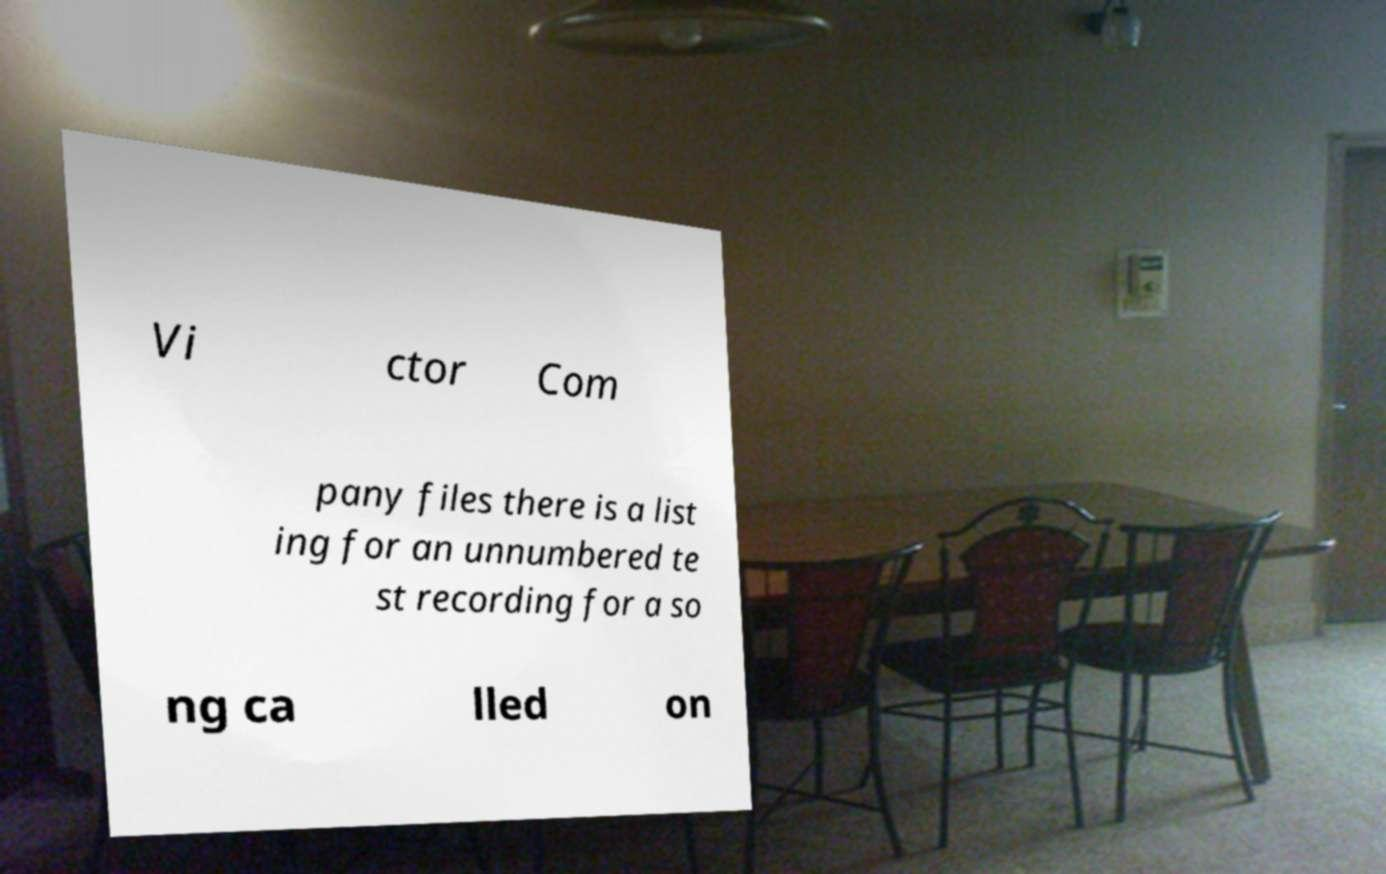What messages or text are displayed in this image? I need them in a readable, typed format. Vi ctor Com pany files there is a list ing for an unnumbered te st recording for a so ng ca lled on 